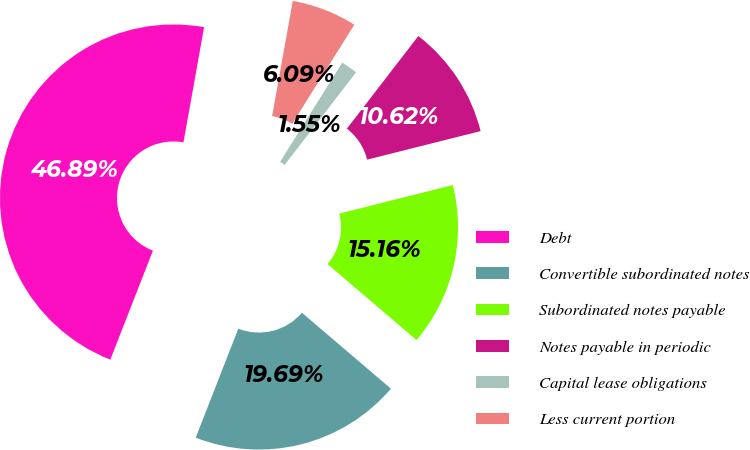Convert chart. <chart><loc_0><loc_0><loc_500><loc_500><pie_chart><fcel>Debt<fcel>Convertible subordinated notes<fcel>Subordinated notes payable<fcel>Notes payable in periodic<fcel>Capital lease obligations<fcel>Less current portion<nl><fcel>46.89%<fcel>19.69%<fcel>15.16%<fcel>10.62%<fcel>1.55%<fcel>6.09%<nl></chart> 